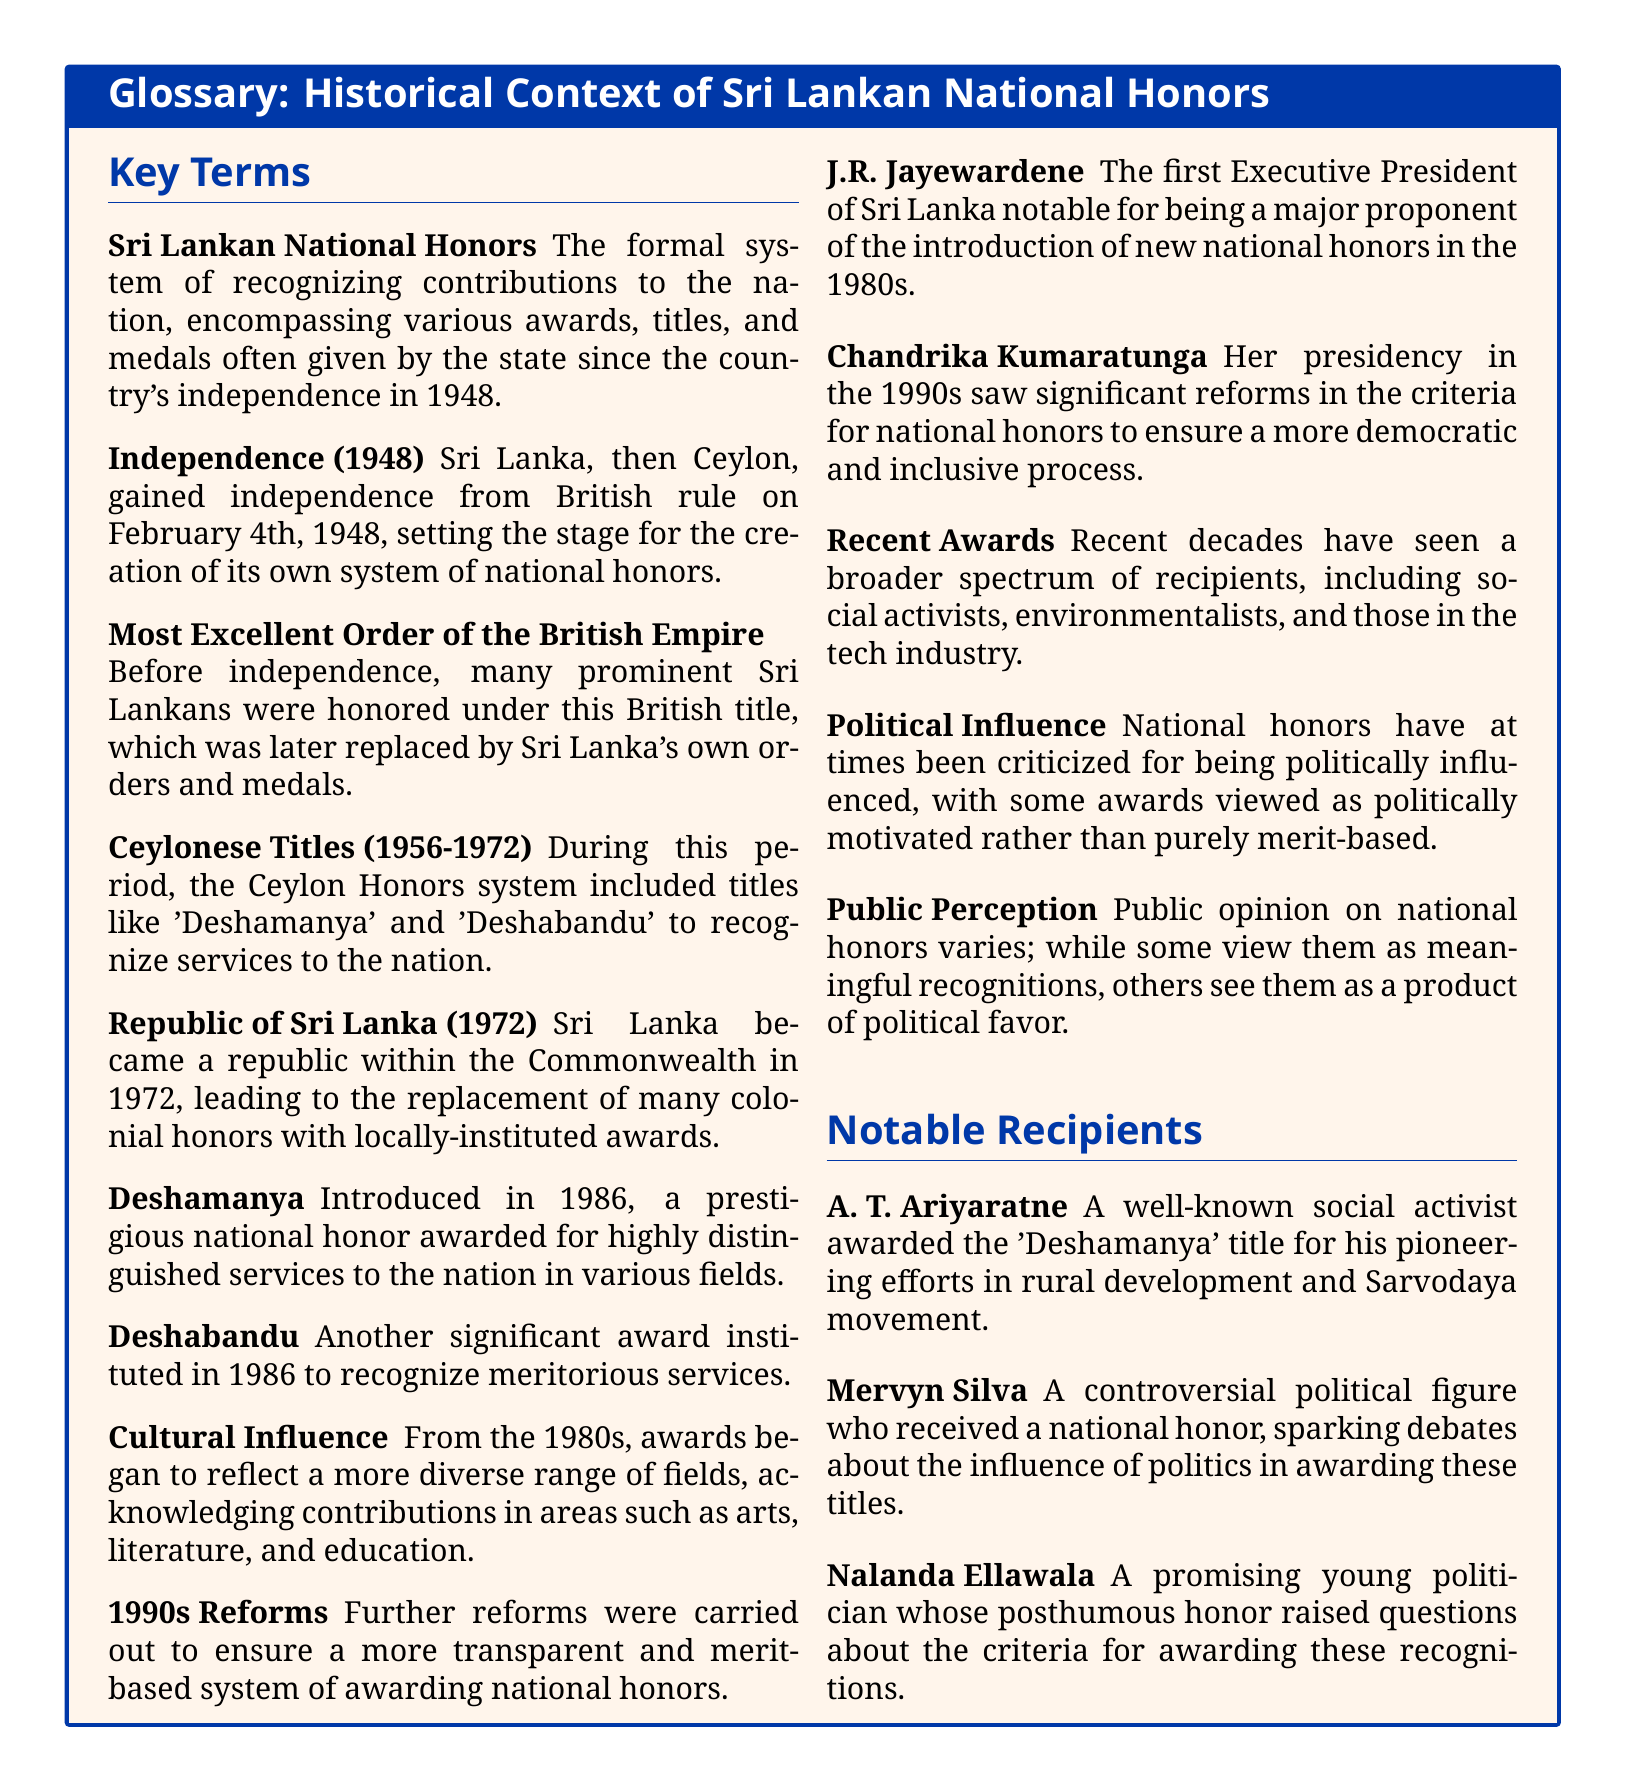What is the year of Sri Lanka's independence? Sri Lanka gained independence on February 4th, 1948, as stated in the document.
Answer: 1948 What title was introduced in 1986 for distinguished services? The document states that the 'Deshamanya' title was introduced in 1986 for highly distinguished services.
Answer: Deshamanya Who was the first Executive President of Sri Lanka? The document notes that J.R. Jayewardene was the first Executive President of Sri Lanka.
Answer: J.R. Jayewardene What was a significant change in national honors during Chandrika Kumaratunga's presidency? The document mentions that significant reforms were made to ensure a more democratic and inclusive process for national honors during her presidency.
Answer: Democratic reforms What honor is awarded for meritorious services and was also instituted in 1986? The document specifies the 'Deshabandu' award as being instituted in 1986 for meritorious services.
Answer: Deshabandu What are the 'Ceylonese Titles' recognized during the period from 1956 to 1972? The document lists titles like 'Deshamanya' and 'Deshabandu' recognized during this period.
Answer: Deshamanya and Deshabandu Which decade saw the introduction of a more transparent and merit-based award system? The document states that the 1990s saw reforms for a more transparent and merit-based system for national honors.
Answer: 1990s What has public perception been regarding national honors? The document indicates that public perception of national honors varies widely among the populace.
Answer: Varies widely Who received a national honor that stirred controversy regarding political influence? Mervyn Silva is mentioned in the document as a controversial political figure who received a national honor.
Answer: Mervyn Silva 